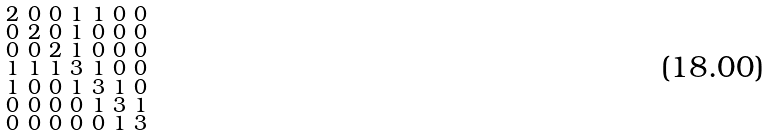Convert formula to latex. <formula><loc_0><loc_0><loc_500><loc_500>\begin{smallmatrix} 2 & 0 & 0 & 1 & 1 & 0 & 0 \\ 0 & 2 & 0 & 1 & 0 & 0 & 0 \\ 0 & 0 & 2 & 1 & 0 & 0 & 0 \\ 1 & 1 & 1 & 3 & 1 & 0 & 0 \\ 1 & 0 & 0 & 1 & 3 & 1 & 0 \\ 0 & 0 & 0 & 0 & 1 & 3 & 1 \\ 0 & 0 & 0 & 0 & 0 & 1 & 3 \end{smallmatrix}</formula> 